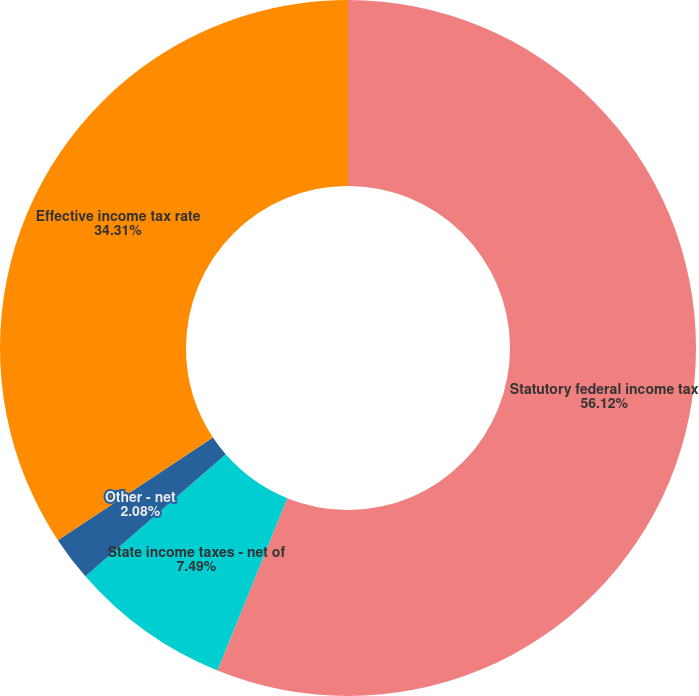<chart> <loc_0><loc_0><loc_500><loc_500><pie_chart><fcel>Statutory federal income tax<fcel>State income taxes - net of<fcel>Other - net<fcel>Effective income tax rate<nl><fcel>56.12%<fcel>7.49%<fcel>2.08%<fcel>34.31%<nl></chart> 